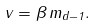<formula> <loc_0><loc_0><loc_500><loc_500>v = \beta \, m _ { d - 1 } .</formula> 